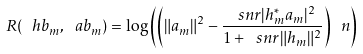<formula> <loc_0><loc_0><loc_500><loc_500>R ( \ h b _ { m } , \ a b _ { m } ) = \log { \left ( \left ( \| a _ { m } \| ^ { 2 } - \frac { \ s n r | h _ { m } ^ { * } a _ { m } | ^ { 2 } } { 1 + \ s n r \| h _ { m } \| ^ { 2 } } \right ) \ n \right ) }</formula> 